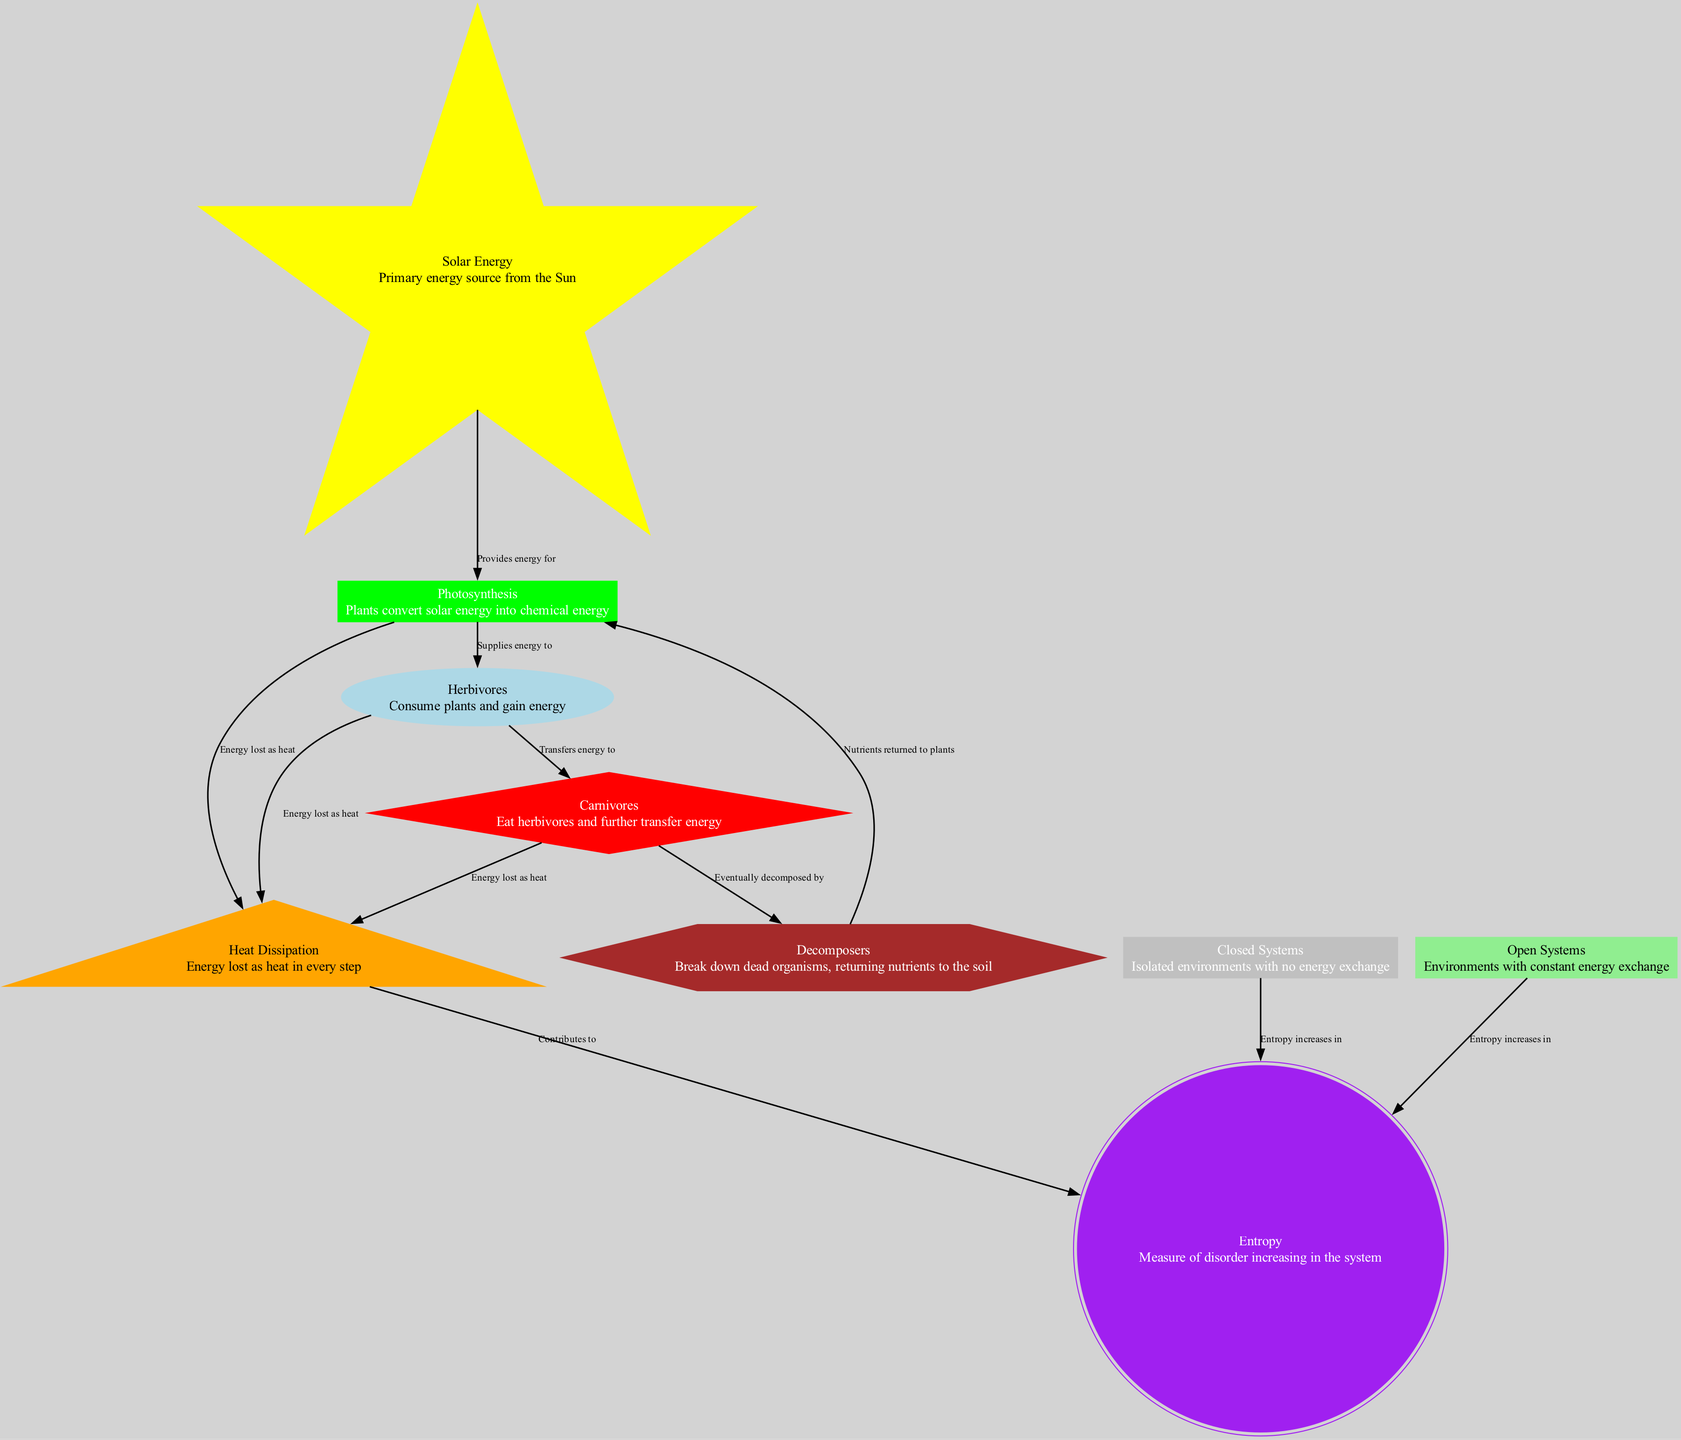What is the primary energy source in this food chain? The primary energy source is represented by the node "Solar Energy", which indicates that it is the starting point of energy transfer in the food chain.
Answer: Solar Energy How many nodes are there in the diagram? To find the total number of nodes, we can count the items listed under the "nodes" section in the data. In this diagram, there are 9 nodes listed.
Answer: 9 What is the relationship between "Photosynthesis" and "Herbivores"? The diagram shows that "Photosynthesis" supplies energy to "Herbivores," indicating a direct energy transfer from plants to herbivorous animals.
Answer: Supplies energy to What happens to energy at each step in the food chain? Each step of the food chain is followed by "Heat Dissipation" which indicates that energy is lost as heat during the transfer between each trophic level.
Answer: Energy lost as heat Which node represents the process of breaking down dead organisms? The node "Decomposers" is responsible for breaking down dead organisms and returning nutrients to the soil, which is a key part of nutrient cycling.
Answer: Decomposers In what type of system does entropy increase? The diagram indicates that entropy increases in both "Closed Systems" and "Open Systems," highlighting that disorder rises regardless of the energy exchange conditions.
Answer: Closed Systems and Open Systems How do "Decomposers" relate to "Photosynthesis"? "Decomposers" eventually return nutrients to "Photosynthesis" by decomposing dead organisms, thereby completing the nutrient cycle necessary for plant growth.
Answer: Eventually decomposed by What is indicated by the "Heat Dissipation" node? The "Heat Dissipation" node signifies the loss of energy as heat with each energy transfer in the food chain, which contributes to the increase in entropy.
Answer: Energy lost as heat Which process converts solar energy into chemical energy? The process represented by the node "Photosynthesis" indicates the conversion of solar energy into chemical energy by plants, which is essential for sustaining life in the food chain.
Answer: Photosynthesis 